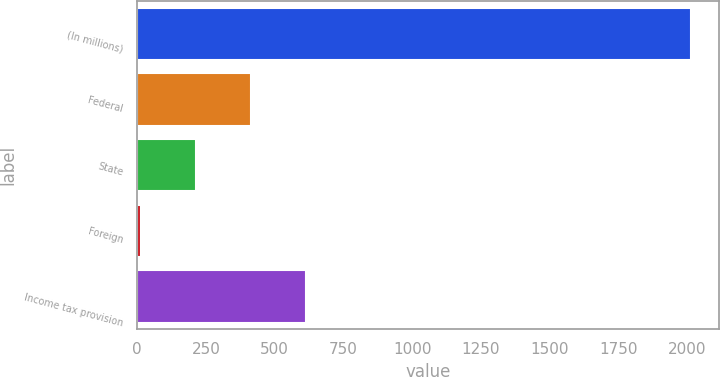<chart> <loc_0><loc_0><loc_500><loc_500><bar_chart><fcel>(In millions)<fcel>Federal<fcel>State<fcel>Foreign<fcel>Income tax provision<nl><fcel>2013<fcel>412.2<fcel>212.1<fcel>12<fcel>612.3<nl></chart> 